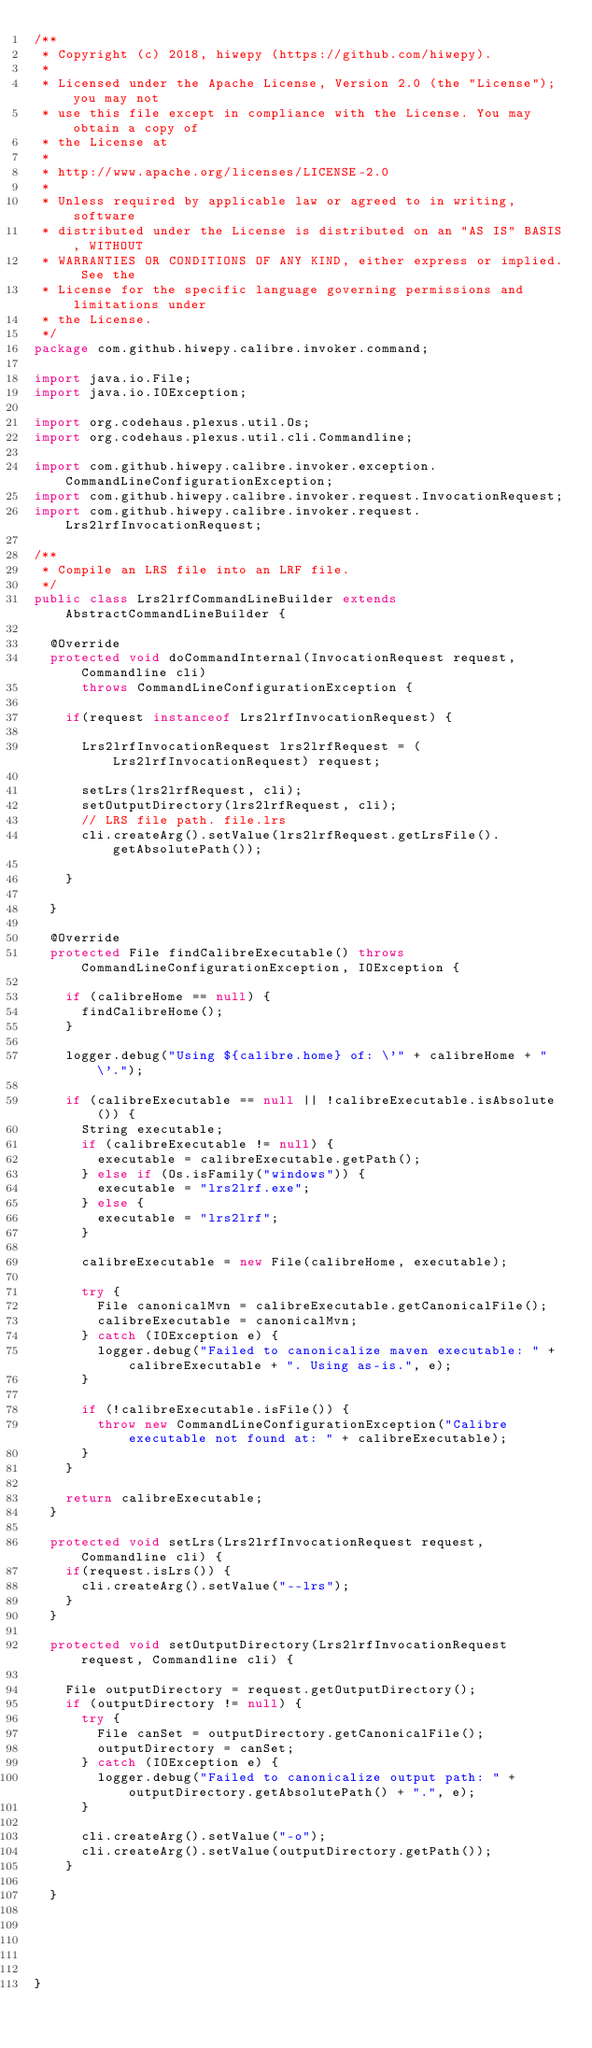<code> <loc_0><loc_0><loc_500><loc_500><_Java_>/**
 * Copyright (c) 2018, hiwepy (https://github.com/hiwepy).
 *
 * Licensed under the Apache License, Version 2.0 (the "License"); you may not
 * use this file except in compliance with the License. You may obtain a copy of
 * the License at
 *
 * http://www.apache.org/licenses/LICENSE-2.0
 *
 * Unless required by applicable law or agreed to in writing, software
 * distributed under the License is distributed on an "AS IS" BASIS, WITHOUT
 * WARRANTIES OR CONDITIONS OF ANY KIND, either express or implied. See the
 * License for the specific language governing permissions and limitations under
 * the License.
 */
package com.github.hiwepy.calibre.invoker.command;

import java.io.File;
import java.io.IOException;

import org.codehaus.plexus.util.Os;
import org.codehaus.plexus.util.cli.Commandline;

import com.github.hiwepy.calibre.invoker.exception.CommandLineConfigurationException;
import com.github.hiwepy.calibre.invoker.request.InvocationRequest;
import com.github.hiwepy.calibre.invoker.request.Lrs2lrfInvocationRequest;

/**
 * Compile an LRS file into an LRF file.
 */
public class Lrs2lrfCommandLineBuilder extends AbstractCommandLineBuilder {

	@Override
	protected void doCommandInternal(InvocationRequest request, Commandline cli)
			throws CommandLineConfigurationException {
		
		if(request instanceof Lrs2lrfInvocationRequest) {

			Lrs2lrfInvocationRequest lrs2lrfRequest = ( Lrs2lrfInvocationRequest) request;
			
			setLrs(lrs2lrfRequest, cli);
			setOutputDirectory(lrs2lrfRequest, cli);
			// LRS file path. file.lrs
			cli.createArg().setValue(lrs2lrfRequest.getLrsFile().getAbsolutePath());
			
		}
		
	}

	@Override
	protected File findCalibreExecutable() throws CommandLineConfigurationException, IOException {
		
		if (calibreHome == null) {
			findCalibreHome();
		}

		logger.debug("Using ${calibre.home} of: \'" + calibreHome + "\'.");

		if (calibreExecutable == null || !calibreExecutable.isAbsolute()) {
			String executable;
			if (calibreExecutable != null) {
				executable = calibreExecutable.getPath();
			} else if (Os.isFamily("windows")) {
				executable = "lrs2lrf.exe";
			} else {
				executable = "lrs2lrf";
			}

			calibreExecutable = new File(calibreHome, executable);

			try {
				File canonicalMvn = calibreExecutable.getCanonicalFile();
				calibreExecutable = canonicalMvn;
			} catch (IOException e) {
				logger.debug("Failed to canonicalize maven executable: " + calibreExecutable + ". Using as-is.", e);
			}

			if (!calibreExecutable.isFile()) {
				throw new CommandLineConfigurationException("Calibre executable not found at: " + calibreExecutable);
			}
		}

		return calibreExecutable;
	}
	
	protected void setLrs(Lrs2lrfInvocationRequest request, Commandline cli) {
		if(request.isLrs()) {
			cli.createArg().setValue("--lrs");
		}
	}

	protected void setOutputDirectory(Lrs2lrfInvocationRequest request, Commandline cli) {
		
		File outputDirectory = request.getOutputDirectory();
		if (outputDirectory != null) {
			try {
				File canSet = outputDirectory.getCanonicalFile();
				outputDirectory = canSet;
			} catch (IOException e) {
				logger.debug("Failed to canonicalize output path: " + outputDirectory.getAbsolutePath() + ".", e);
			}

			cli.createArg().setValue("-o");
			cli.createArg().setValue(outputDirectory.getPath());
		}
 
	}

	
	 
	

}
</code> 